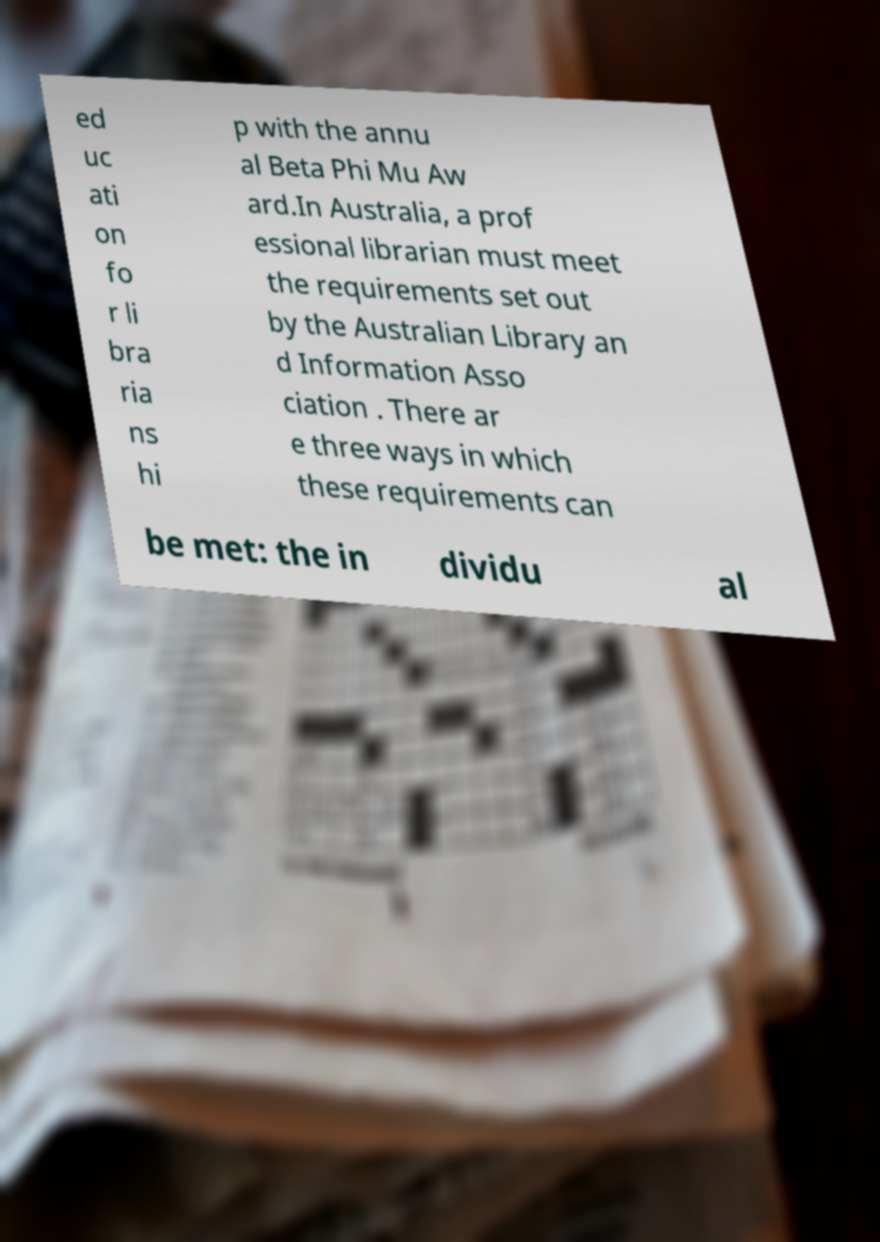There's text embedded in this image that I need extracted. Can you transcribe it verbatim? ed uc ati on fo r li bra ria ns hi p with the annu al Beta Phi Mu Aw ard.In Australia, a prof essional librarian must meet the requirements set out by the Australian Library an d Information Asso ciation . There ar e three ways in which these requirements can be met: the in dividu al 